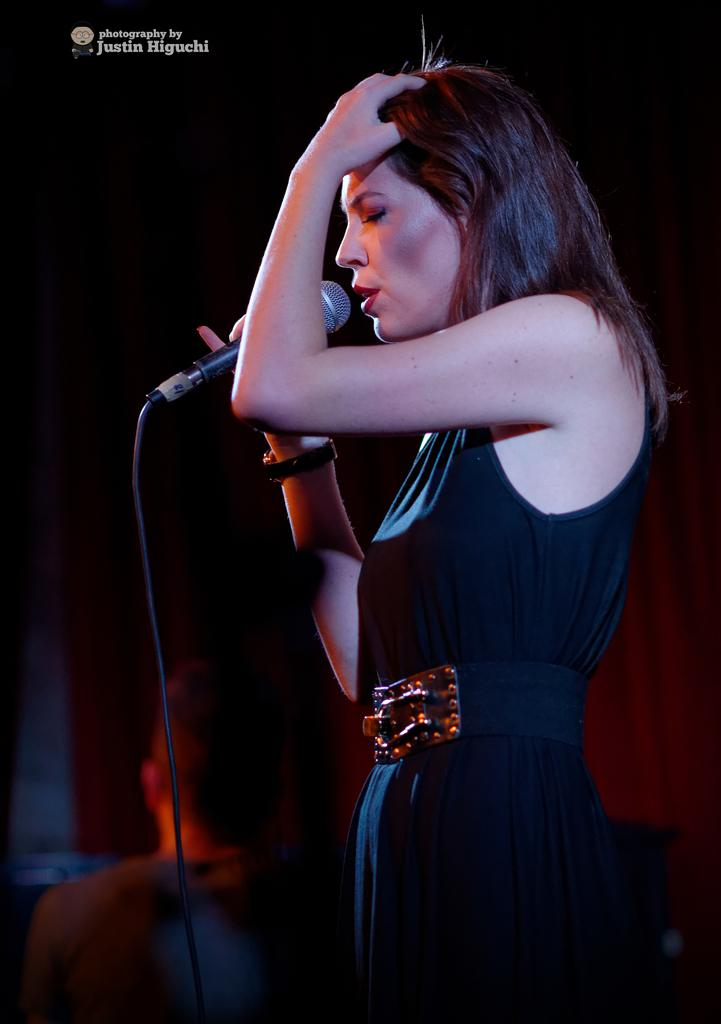Who is the main subject in the image? There is a woman in the image. What is the woman doing in the image? The woman is standing and singing a song. What is the woman holding in her hand? The woman is holding a mike in her hand. Can you describe the woman's attire in the image? The woman is wearing a black dress. Is there anyone else visible in the image? Yes, there is another person in the background of the image. What type of furniture can be seen being smashed by the woman in the image? There is no furniture being smashed in the image; the woman is singing with a mike in her hand. 